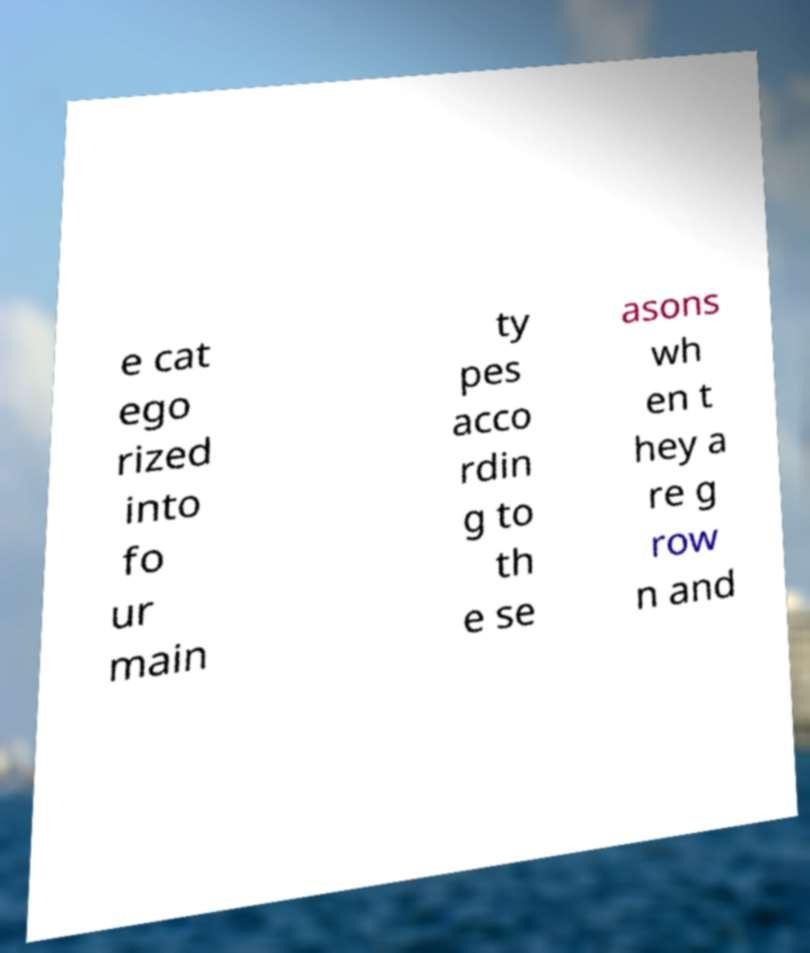Please read and relay the text visible in this image. What does it say? e cat ego rized into fo ur main ty pes acco rdin g to th e se asons wh en t hey a re g row n and 